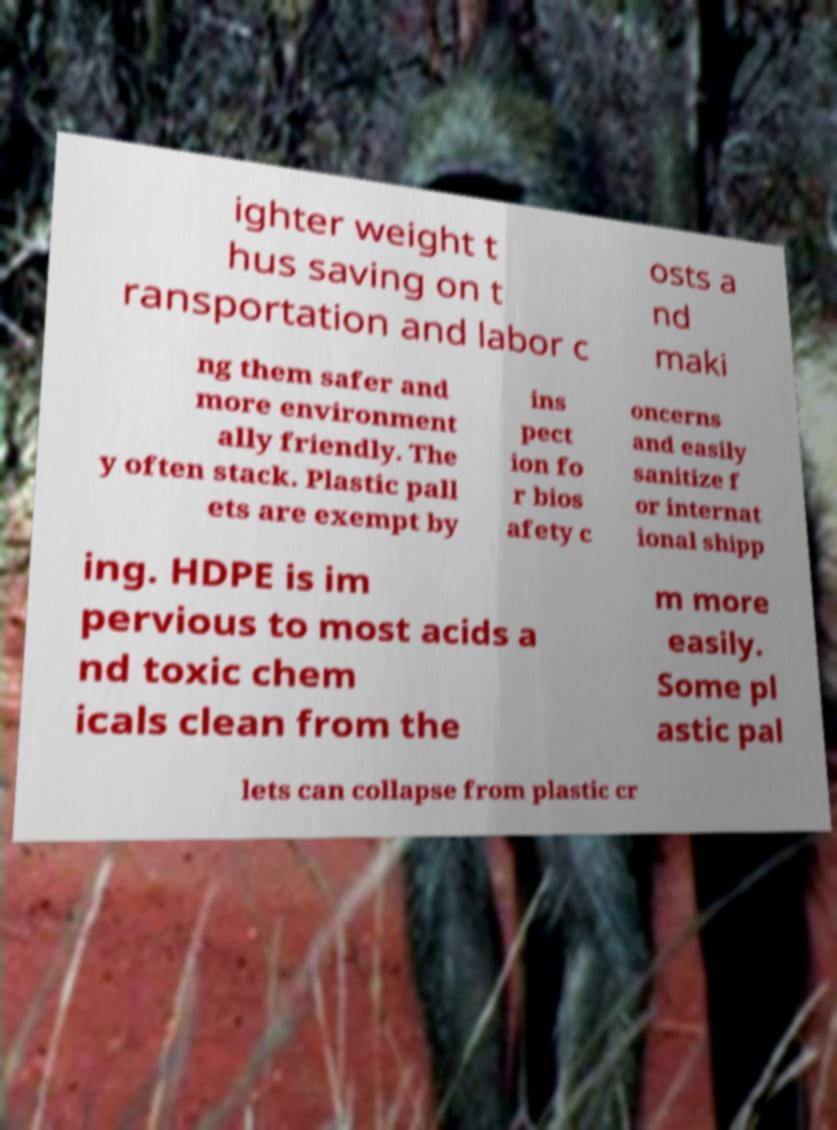Could you assist in decoding the text presented in this image and type it out clearly? ighter weight t hus saving on t ransportation and labor c osts a nd maki ng them safer and more environment ally friendly. The y often stack. Plastic pall ets are exempt by ins pect ion fo r bios afety c oncerns and easily sanitize f or internat ional shipp ing. HDPE is im pervious to most acids a nd toxic chem icals clean from the m more easily. Some pl astic pal lets can collapse from plastic cr 